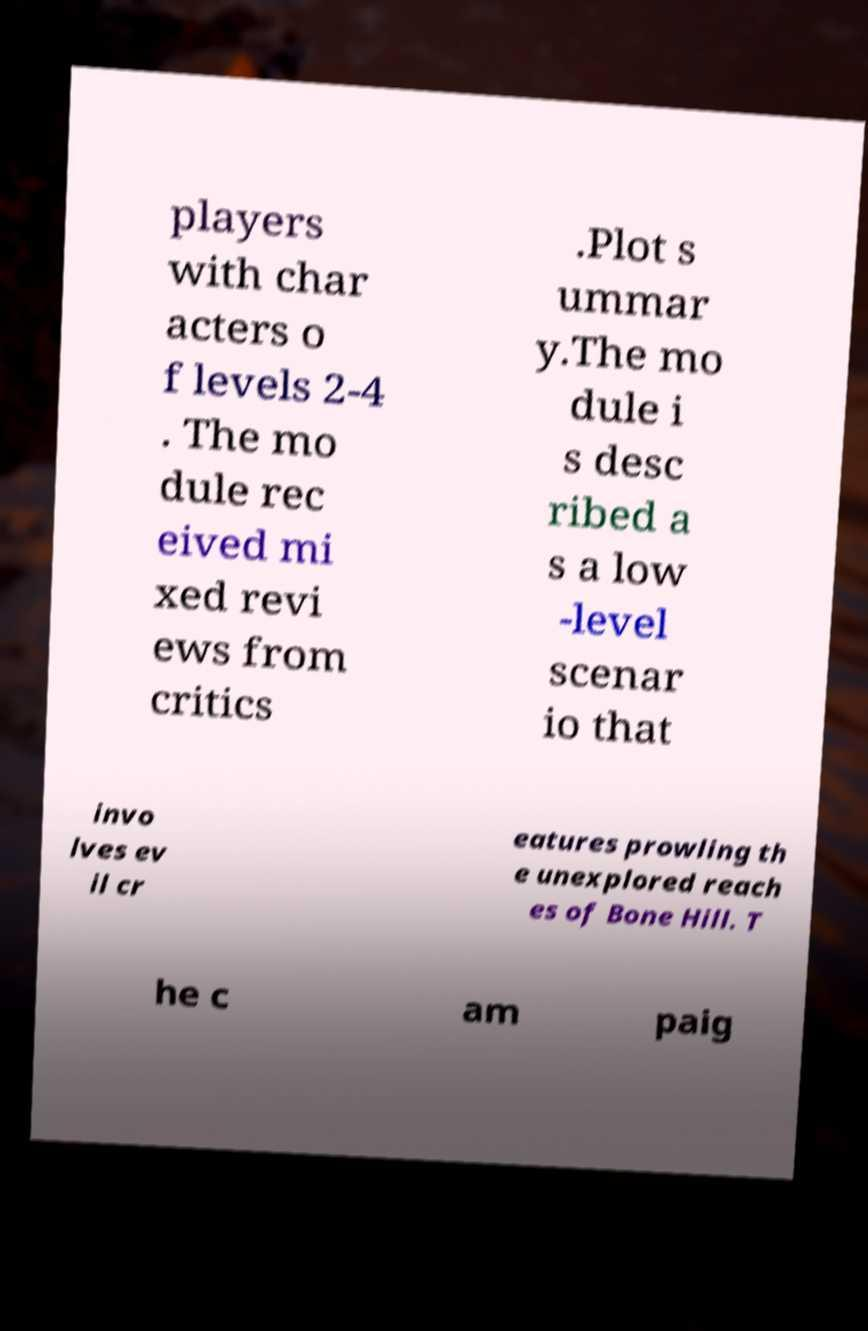Can you accurately transcribe the text from the provided image for me? players with char acters o f levels 2-4 . The mo dule rec eived mi xed revi ews from critics .Plot s ummar y.The mo dule i s desc ribed a s a low -level scenar io that invo lves ev il cr eatures prowling th e unexplored reach es of Bone Hill. T he c am paig 